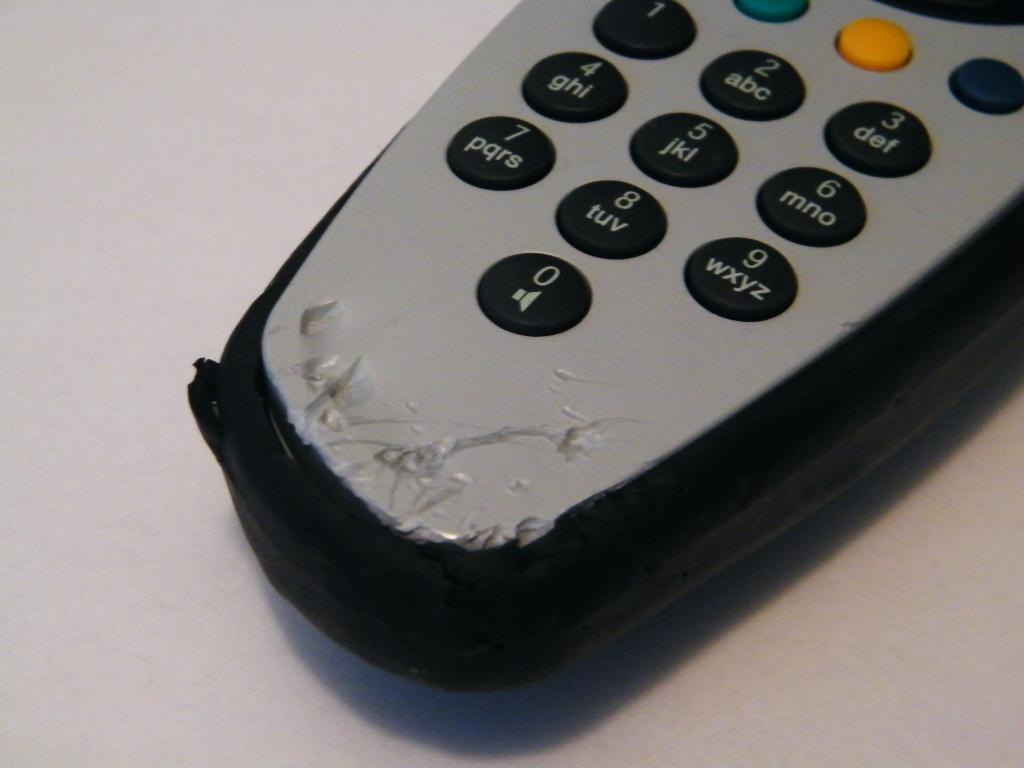<image>
Offer a succinct explanation of the picture presented. A remote control with 0 as a volume button appears to be chewed up at the bottom. 